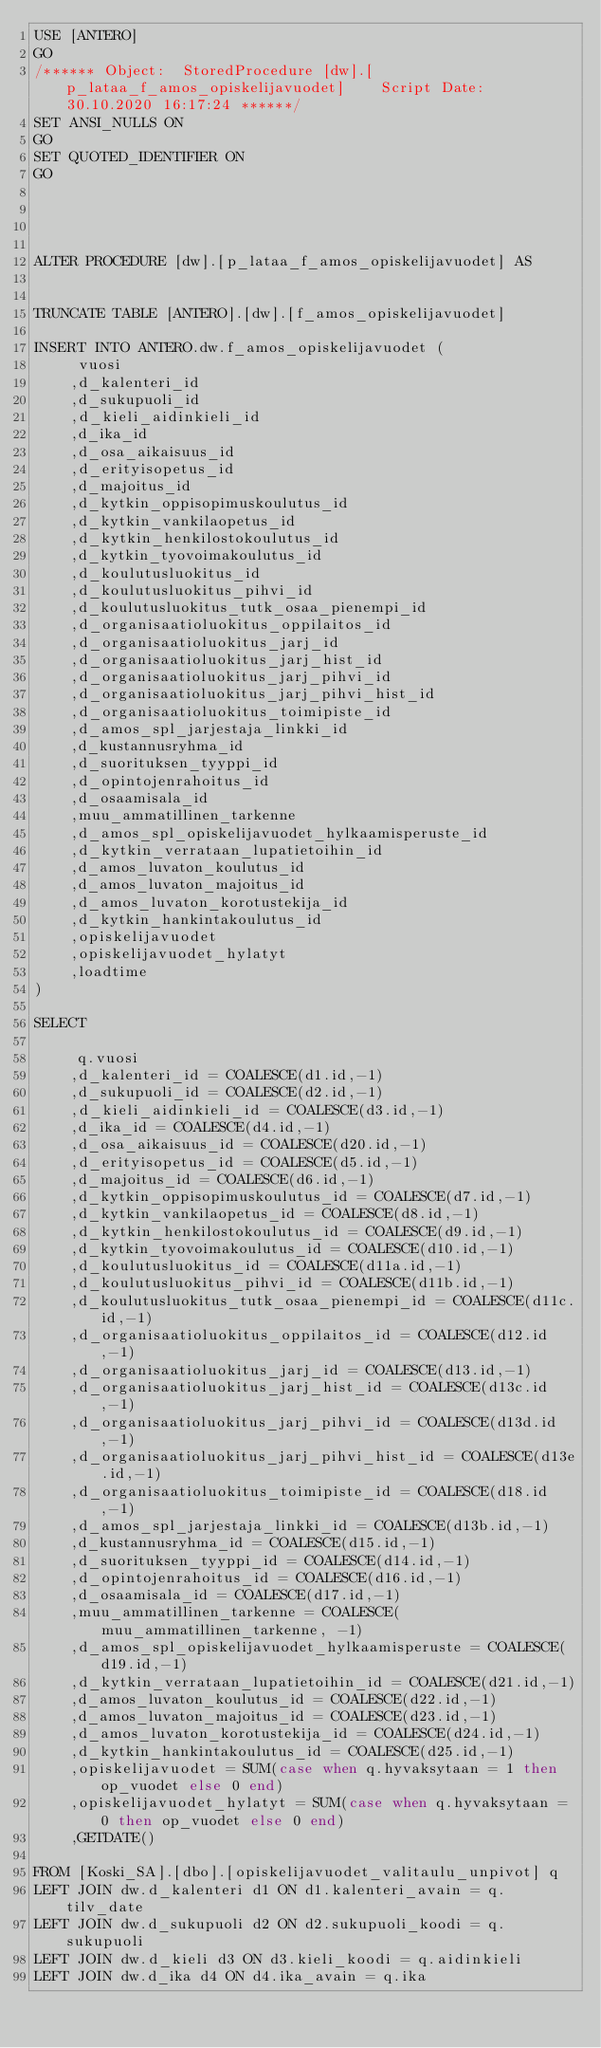<code> <loc_0><loc_0><loc_500><loc_500><_SQL_>USE [ANTERO]
GO
/****** Object:  StoredProcedure [dw].[p_lataa_f_amos_opiskelijavuodet]    Script Date: 30.10.2020 16:17:24 ******/
SET ANSI_NULLS ON
GO
SET QUOTED_IDENTIFIER ON
GO




ALTER PROCEDURE [dw].[p_lataa_f_amos_opiskelijavuodet] AS


TRUNCATE TABLE [ANTERO].[dw].[f_amos_opiskelijavuodet]

INSERT INTO ANTERO.dw.f_amos_opiskelijavuodet (
	 vuosi
	,d_kalenteri_id
	,d_sukupuoli_id
	,d_kieli_aidinkieli_id
	,d_ika_id
	,d_osa_aikaisuus_id
	,d_erityisopetus_id
	,d_majoitus_id
	,d_kytkin_oppisopimuskoulutus_id
	,d_kytkin_vankilaopetus_id
	,d_kytkin_henkilostokoulutus_id
	,d_kytkin_tyovoimakoulutus_id
	,d_koulutusluokitus_id
	,d_koulutusluokitus_pihvi_id
	,d_koulutusluokitus_tutk_osaa_pienempi_id
	,d_organisaatioluokitus_oppilaitos_id
	,d_organisaatioluokitus_jarj_id
	,d_organisaatioluokitus_jarj_hist_id
	,d_organisaatioluokitus_jarj_pihvi_id
	,d_organisaatioluokitus_jarj_pihvi_hist_id
	,d_organisaatioluokitus_toimipiste_id
	,d_amos_spl_jarjestaja_linkki_id
	,d_kustannusryhma_id
	,d_suorituksen_tyyppi_id
	,d_opintojenrahoitus_id
	,d_osaamisala_id
	,muu_ammatillinen_tarkenne
	,d_amos_spl_opiskelijavuodet_hylkaamisperuste_id
	,d_kytkin_verrataan_lupatietoihin_id
	,d_amos_luvaton_koulutus_id
	,d_amos_luvaton_majoitus_id
	,d_amos_luvaton_korotustekija_id
	,d_kytkin_hankintakoulutus_id
	,opiskelijavuodet
	,opiskelijavuodet_hylatyt
	,loadtime
)

SELECT 
	
	 q.vuosi
	,d_kalenteri_id = COALESCE(d1.id,-1)
	,d_sukupuoli_id = COALESCE(d2.id,-1)
	,d_kieli_aidinkieli_id = COALESCE(d3.id,-1)
	,d_ika_id = COALESCE(d4.id,-1)
	,d_osa_aikaisuus_id = COALESCE(d20.id,-1)
	,d_erityisopetus_id = COALESCE(d5.id,-1)
	,d_majoitus_id = COALESCE(d6.id,-1)
	,d_kytkin_oppisopimuskoulutus_id = COALESCE(d7.id,-1)
	,d_kytkin_vankilaopetus_id = COALESCE(d8.id,-1)
	,d_kytkin_henkilostokoulutus_id = COALESCE(d9.id,-1)
	,d_kytkin_tyovoimakoulutus_id = COALESCE(d10.id,-1)
	,d_koulutusluokitus_id = COALESCE(d11a.id,-1)
	,d_koulutusluokitus_pihvi_id = COALESCE(d11b.id,-1)
	,d_koulutusluokitus_tutk_osaa_pienempi_id = COALESCE(d11c.id,-1)
	,d_organisaatioluokitus_oppilaitos_id = COALESCE(d12.id,-1)
	,d_organisaatioluokitus_jarj_id = COALESCE(d13.id,-1)
	,d_organisaatioluokitus_jarj_hist_id = COALESCE(d13c.id,-1)
	,d_organisaatioluokitus_jarj_pihvi_id = COALESCE(d13d.id,-1)
	,d_organisaatioluokitus_jarj_pihvi_hist_id = COALESCE(d13e.id,-1)
	,d_organisaatioluokitus_toimipiste_id = COALESCE(d18.id,-1)
	,d_amos_spl_jarjestaja_linkki_id = COALESCE(d13b.id,-1)
	,d_kustannusryhma_id = COALESCE(d15.id,-1)
	,d_suorituksen_tyyppi_id = COALESCE(d14.id,-1)
	,d_opintojenrahoitus_id = COALESCE(d16.id,-1)
	,d_osaamisala_id = COALESCE(d17.id,-1)
	,muu_ammatillinen_tarkenne = COALESCE(muu_ammatillinen_tarkenne, -1)
	,d_amos_spl_opiskelijavuodet_hylkaamisperuste = COALESCE(d19.id,-1)
	,d_kytkin_verrataan_lupatietoihin_id = COALESCE(d21.id,-1)
	,d_amos_luvaton_koulutus_id = COALESCE(d22.id,-1)
	,d_amos_luvaton_majoitus_id = COALESCE(d23.id,-1)
	,d_amos_luvaton_korotustekija_id = COALESCE(d24.id,-1)
	,d_kytkin_hankintakoulutus_id = COALESCE(d25.id,-1)
	,opiskelijavuodet = SUM(case when q.hyvaksytaan = 1 then op_vuodet else 0 end)
	,opiskelijavuodet_hylatyt = SUM(case when q.hyvaksytaan = 0 then op_vuodet else 0 end)
	,GETDATE()
	
FROM [Koski_SA].[dbo].[opiskelijavuodet_valitaulu_unpivot] q
LEFT JOIN dw.d_kalenteri d1 ON d1.kalenteri_avain = q.tilv_date
LEFT JOIN dw.d_sukupuoli d2 ON d2.sukupuoli_koodi = q.sukupuoli
LEFT JOIN dw.d_kieli d3 ON d3.kieli_koodi = q.aidinkieli
LEFT JOIN dw.d_ika d4 ON d4.ika_avain = q.ika</code> 